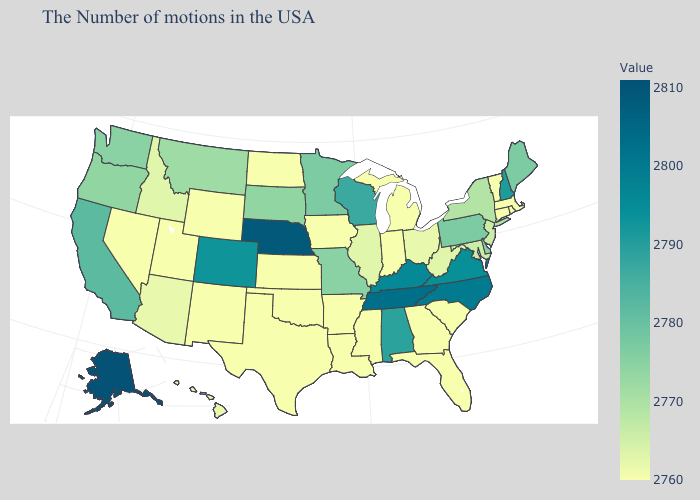Among the states that border Oregon , which have the lowest value?
Give a very brief answer. Nevada. Does Wyoming have the lowest value in the USA?
Answer briefly. Yes. Among the states that border Idaho , does Oregon have the lowest value?
Keep it brief. No. Which states have the highest value in the USA?
Keep it brief. Alaska. Does North Dakota have a lower value than New Hampshire?
Give a very brief answer. Yes. 